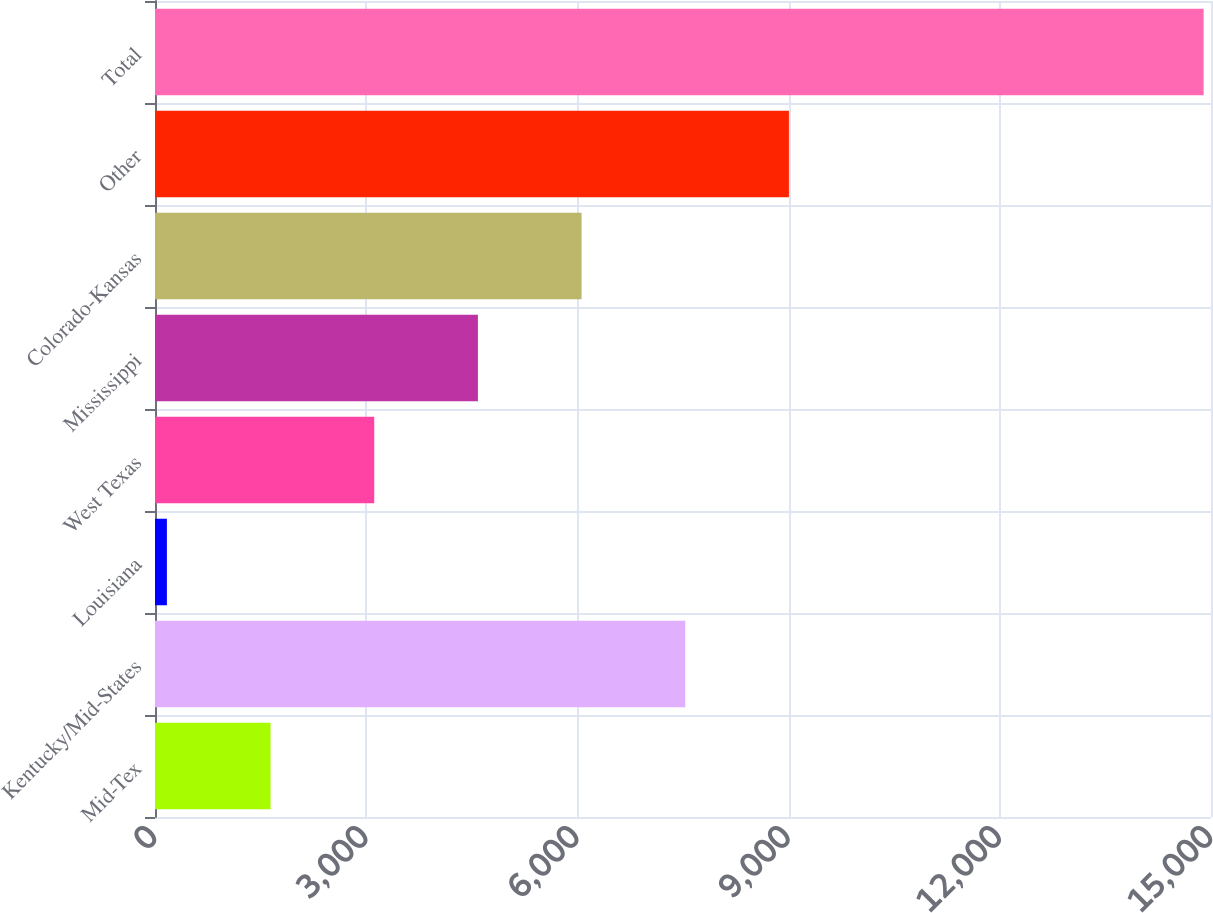Convert chart. <chart><loc_0><loc_0><loc_500><loc_500><bar_chart><fcel>Mid-Tex<fcel>Kentucky/Mid-States<fcel>Louisiana<fcel>West Texas<fcel>Mississippi<fcel>Colorado-Kansas<fcel>Other<fcel>Total<nl><fcel>1641.6<fcel>7532<fcel>169<fcel>3114.2<fcel>4586.8<fcel>6059.4<fcel>9004.6<fcel>14895<nl></chart> 